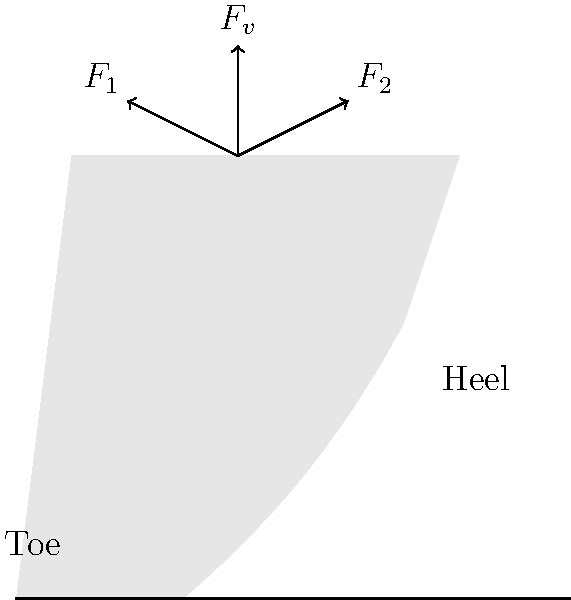A samba dancer's high-heeled shoe experiences various forces during a performance. Given that the vertical force $F_v = 600 \text{ N}$ is applied at the center of the heel, and the reaction forces at the toe ($F_1$) and heel ($F_2$) are at angles of 45° and 30° respectively from the vertical, calculate the magnitude of $F_1$ and $F_2$. Assume the shoe is in static equilibrium. To solve this problem, we'll use the principles of static equilibrium:

1) First, let's break down the forces into their vertical and horizontal components:

   $F_1$ components: $F_{1x} = F_1 \cos 45°$, $F_{1y} = F_1 \sin 45°$
   $F_2$ components: $F_{2x} = F_2 \cos 30°$, $F_{2y} = F_2 \sin 30°$

2) Now, we can set up the equilibrium equations:

   Vertical equilibrium: $F_v = F_{1y} + F_{2y}$
   $600 = F_1 \sin 45° + F_2 \sin 30°$

   Horizontal equilibrium: $F_{1x} = F_{2x}$
   $F_1 \cos 45° = F_2 \cos 30°$

3) From the horizontal equilibrium, we can express $F_2$ in terms of $F_1$:

   $F_2 = F_1 \frac{\cos 45°}{\cos 30°} = F_1 \cdot 0.816$

4) Substitute this into the vertical equilibrium equation:

   $600 = F_1 \sin 45° + (F_1 \cdot 0.816) \sin 30°$
   $600 = 0.707F_1 + 0.408F_1$
   $600 = 1.115F_1$

5) Solve for $F_1$:

   $F_1 = \frac{600}{1.115} = 538.12 \text{ N}$

6) Calculate $F_2$:

   $F_2 = 538.12 \cdot 0.816 = 439.10 \text{ N}$

Therefore, the magnitudes of the reaction forces are:
$F_1 \approx 538 \text{ N}$ and $F_2 \approx 439 \text{ N}$.
Answer: $F_1 \approx 538 \text{ N}$, $F_2 \approx 439 \text{ N}$ 